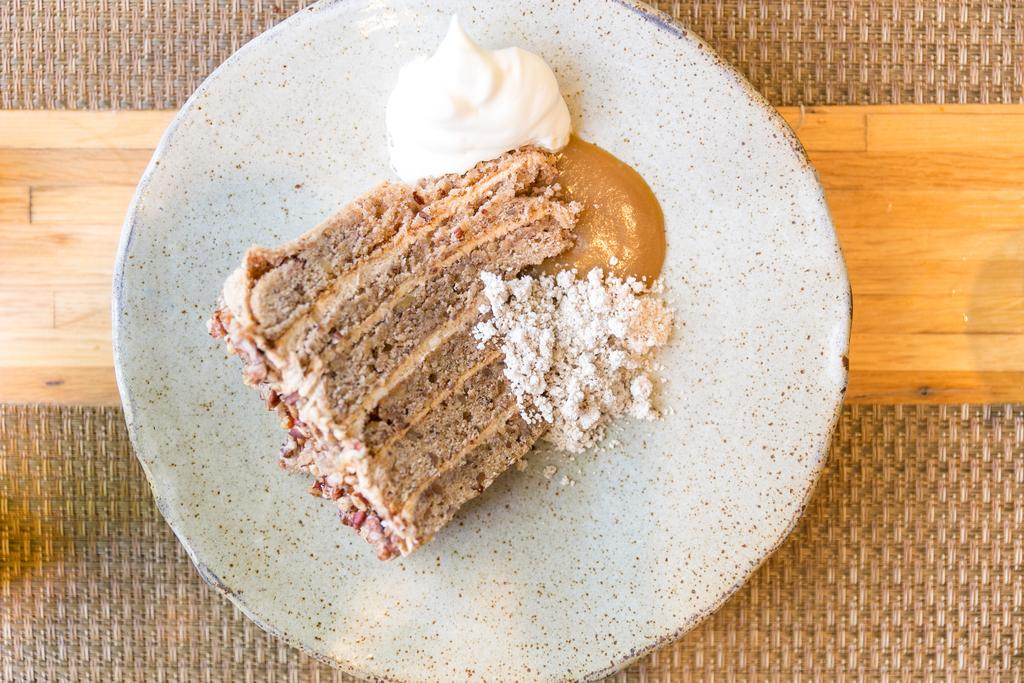What type of objects can be seen in the image? There are food items in the image. On what surface are the food items placed? The food items are placed on a wooden surface. How many spiders can be seen crawling on the girl's car in the image? There are no spiders or cars present in the image; it only features food items placed on a wooden surface. 